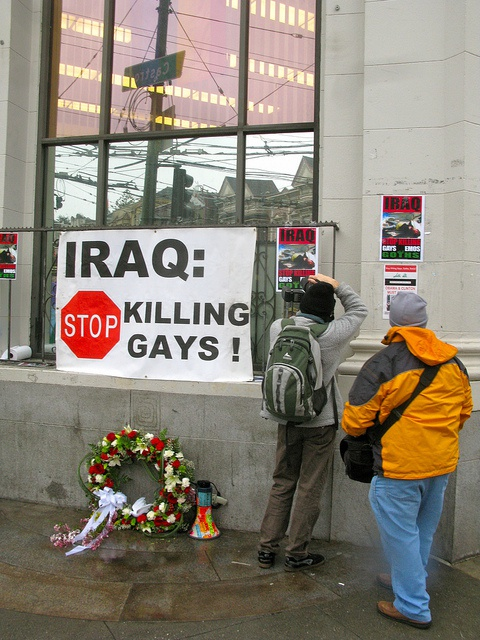Describe the objects in this image and their specific colors. I can see people in darkgray, orange, gray, and red tones, people in darkgray, black, gray, and darkgreen tones, backpack in darkgray, black, gray, and darkgreen tones, stop sign in darkgray, red, lightgray, salmon, and lightpink tones, and handbag in darkgray, black, maroon, brown, and orange tones in this image. 